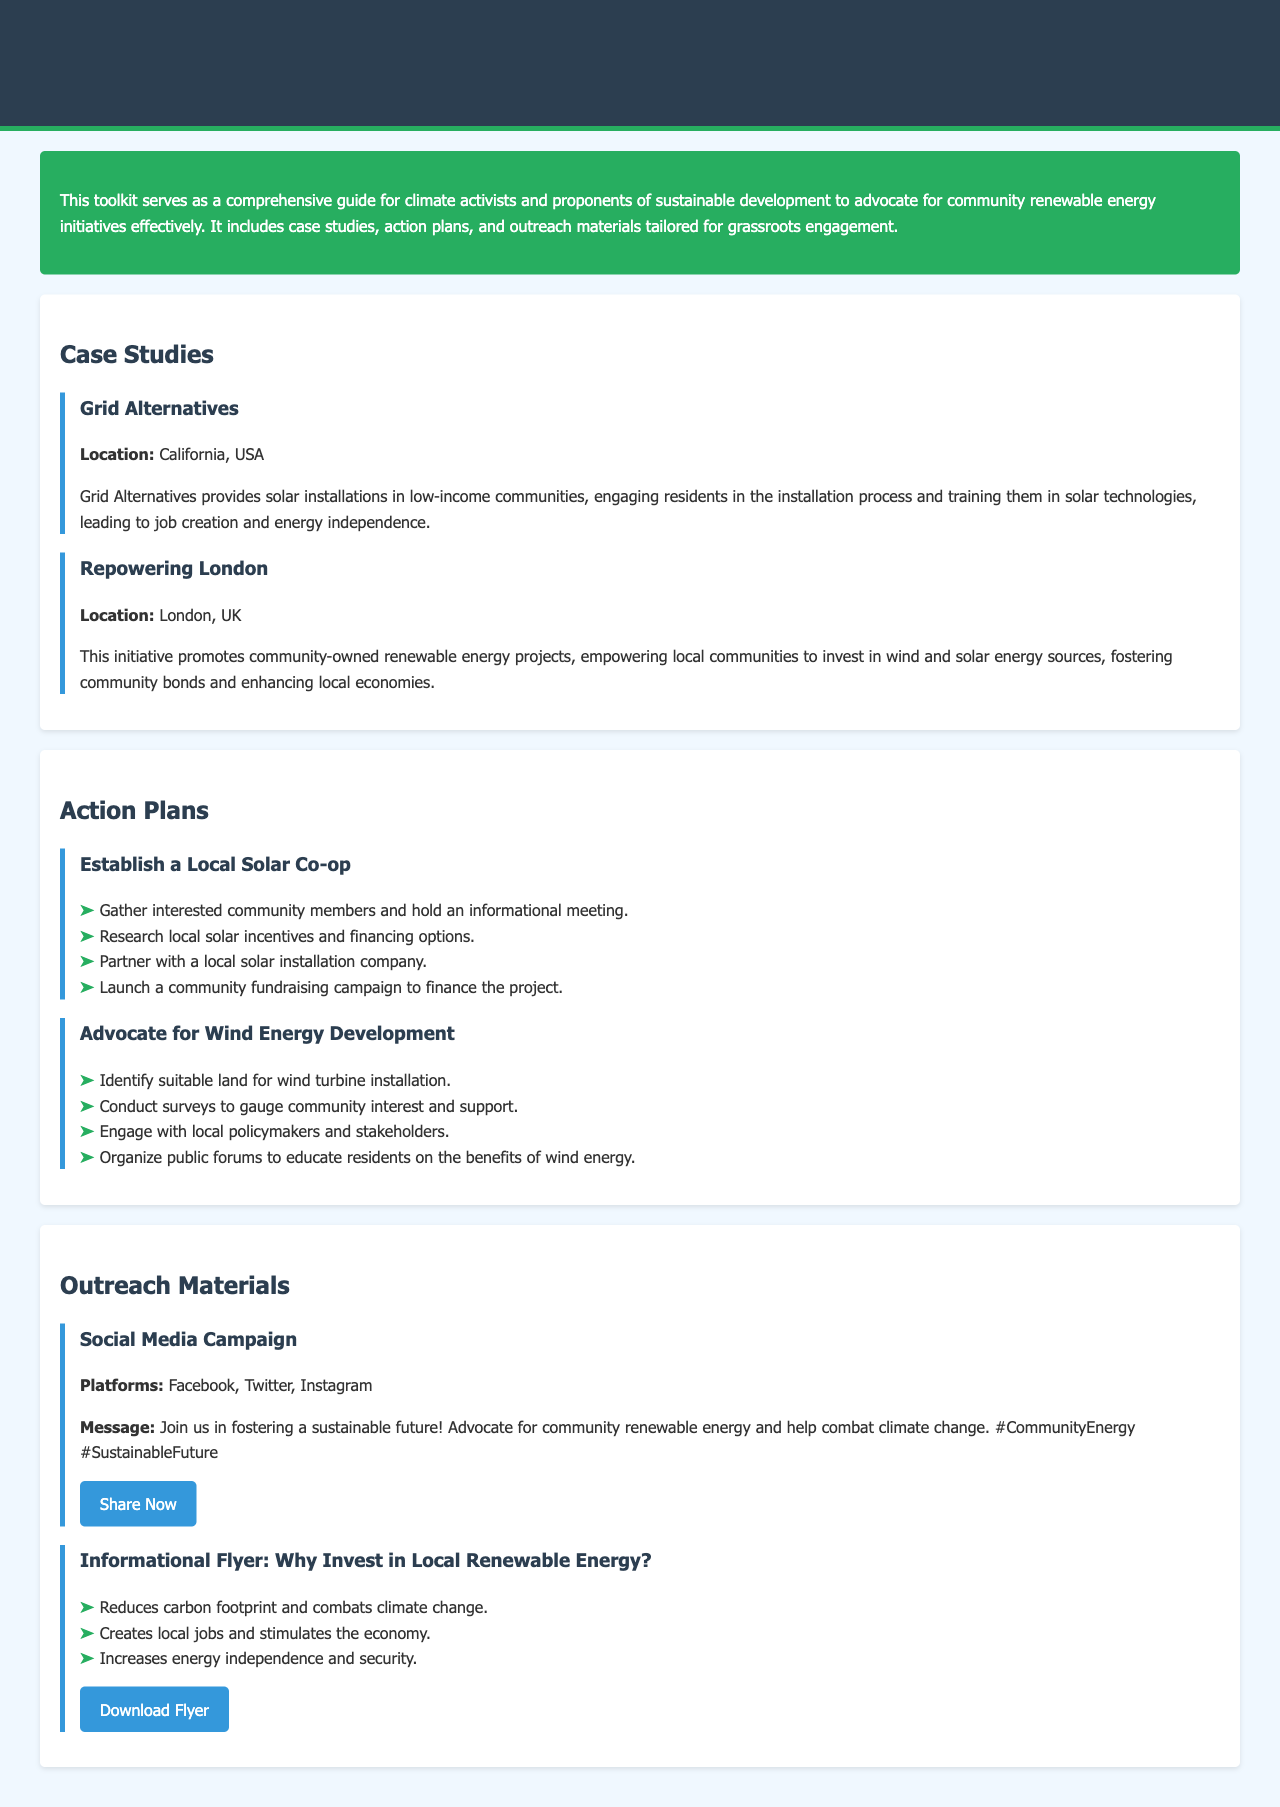What is the purpose of the toolkit? The introduction states that the toolkit serves as a comprehensive guide for climate activists and proponents of sustainable development to advocate for community renewable energy initiatives effectively.
Answer: Advocate for community renewable energy initiatives Where is Grid Alternatives located? In the case study section, it specifies the location of Grid Alternatives as California, USA.
Answer: California, USA What is one benefit of local renewable energy investments mentioned in the flyer? The outreach materials list several benefits, one of them being that it creates local jobs and stimulates the economy.
Answer: Creates local jobs What initiative promotes community-owned renewable energy projects? The case study section describes "Repowering London" as promoting community-owned renewable energy projects.
Answer: Repowering London How many steps are there in the action plan to establish a local solar co-op? The action plan section outlines four steps to establish a local solar co-op.
Answer: Four steps What social media platforms are suggested for the campaign? The outreach material for the social media campaign lists Facebook, Twitter, and Instagram as the suggested platforms.
Answer: Facebook, Twitter, Instagram Which location focuses on wind and solar energy investment? The case study for "Repowering London" emphasizes investment in wind and solar energy sources.
Answer: London, UK What is the message of the social media campaign? The outreach material states that the message for the social media campaign is about fostering a sustainable future through community renewable energy advocacy.
Answer: Fostering a sustainable future What is one action to advocate for wind energy development? One of the actions listed is to engage with local policymakers and stakeholders.
Answer: Engage with local policymakers 